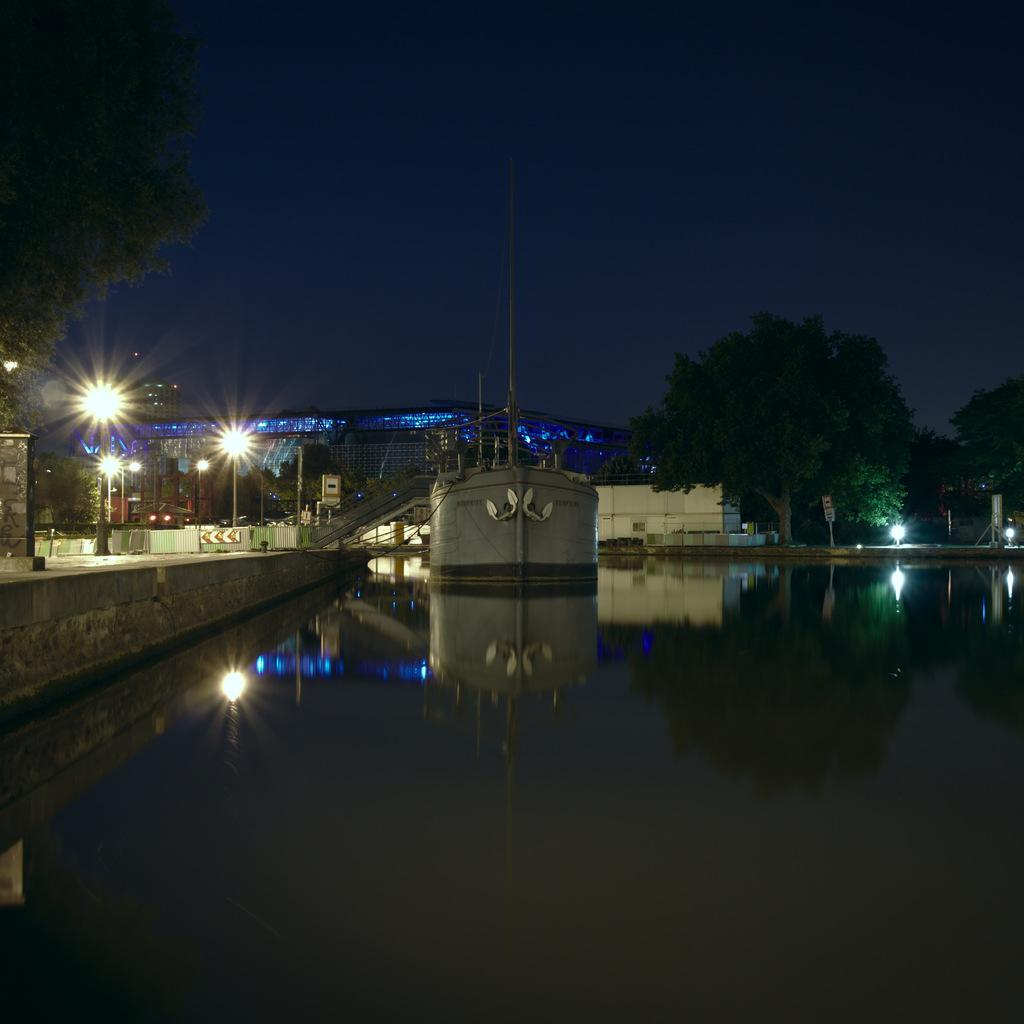What type of structures can be seen in the image? There are buildings in the image. What military vehicle is present in the image? There is a tank in the image. What can be seen in the water in the image? There are reflections in the water. What architectural feature is visible in the image? There are stairs in the image. What type of lighting is present in the image? There are street lights in the image. What type of vegetation is visible in the image? There are trees in the image. What part of the natural environment is visible in the image? The sky is visible in the image. How many legs does the army use to move in the image? There is no army present in the image, and therefore no legs to count. What type of stitch is used to hold the tank together in the image? The image does not show the internal structure of the tank, so it is not possible to determine the type of stitch used. 